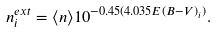Convert formula to latex. <formula><loc_0><loc_0><loc_500><loc_500>n ^ { e x t } _ { i } = \langle n \rangle 1 0 ^ { - 0 . 4 5 ( 4 . 0 3 5 E ( B - V ) _ { i } ) } .</formula> 